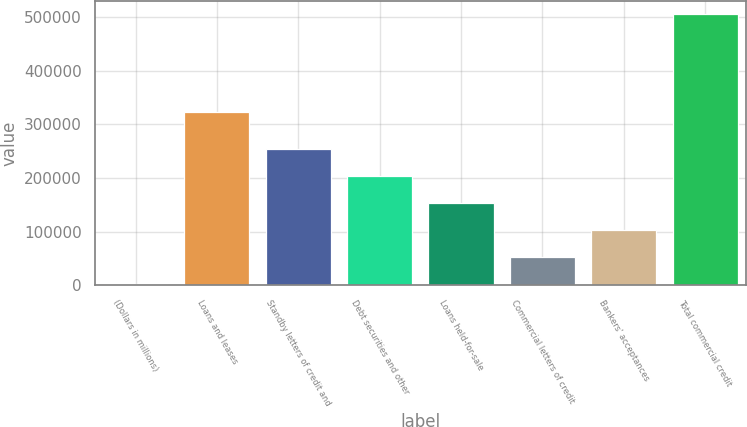Convert chart. <chart><loc_0><loc_0><loc_500><loc_500><bar_chart><fcel>(Dollars in millions)<fcel>Loans and leases<fcel>Standby letters of credit and<fcel>Debt securities and other<fcel>Loans held-for-sale<fcel>Commercial letters of credit<fcel>Bankers' acceptances<fcel>Total commercial credit<nl><fcel>2009<fcel>322564<fcel>253753<fcel>203404<fcel>153055<fcel>52357.8<fcel>102707<fcel>505497<nl></chart> 